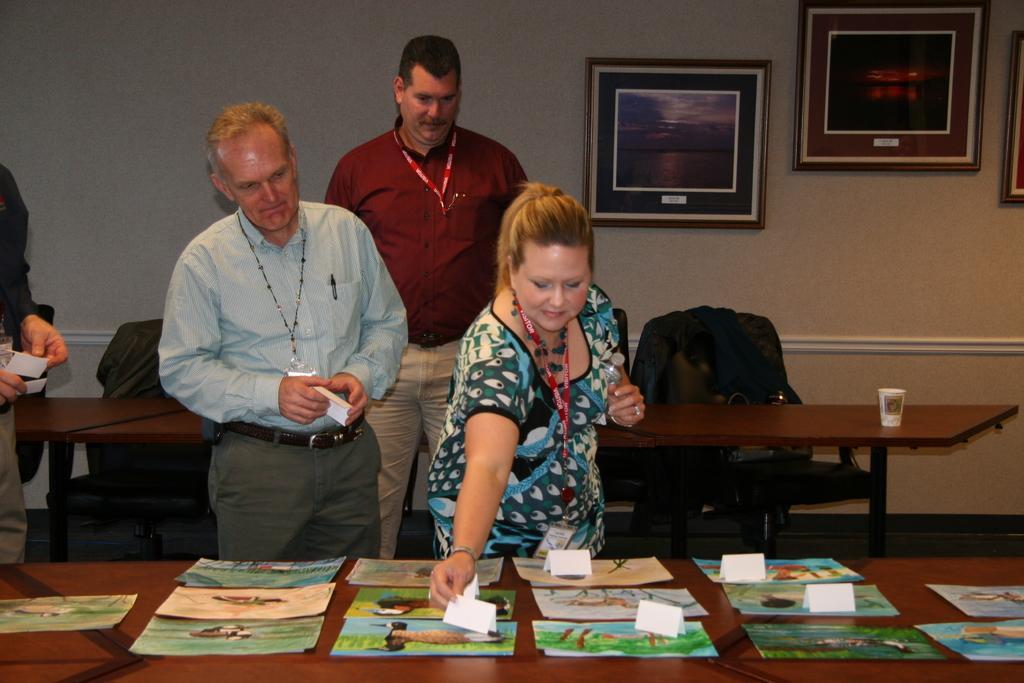Please provide a concise description of this image. In this picture we can see four people where a woman standing and holding a paper with her hand and in front of them on tables we can see a cup, books on it and in the background we can see chairs and frames on the wall. 